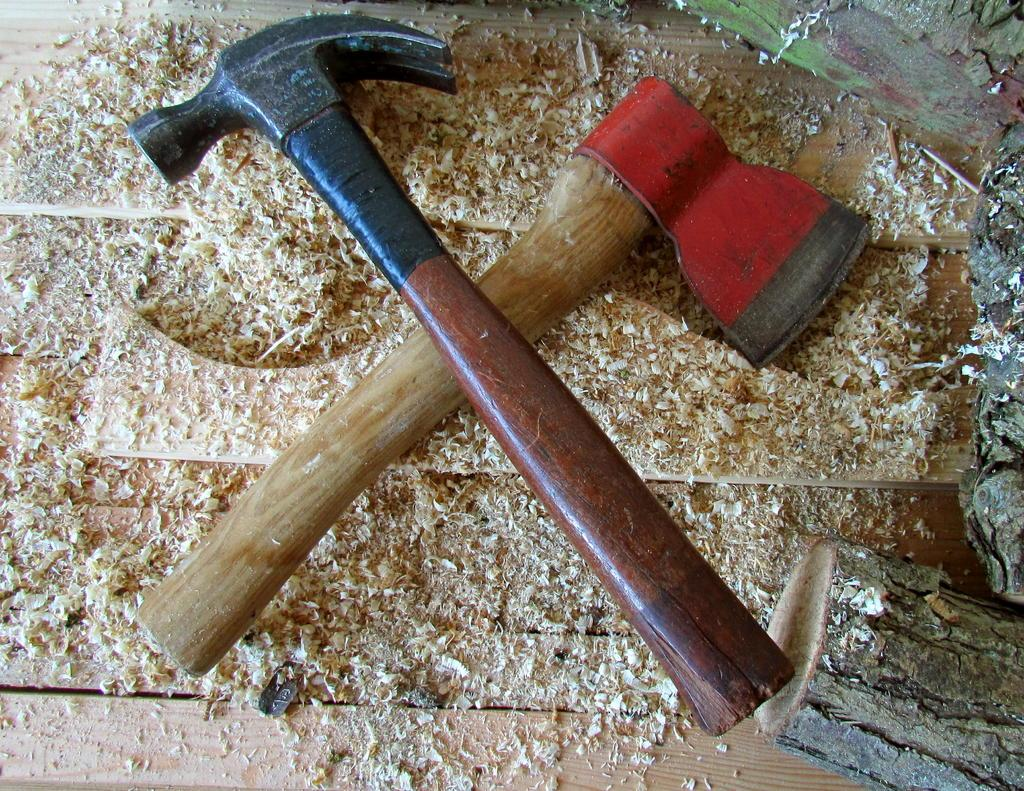What type of tools can be seen in the image? There is an axe and a hammer in the image. What objects are being worked on in the image? There are wooden logs in the image. What might be a byproduct of working with the wooden logs? There is sawdust on a wooden surface in the image, which could be a byproduct of working with the wooden logs. What type of ticket is visible in the image? There is no ticket present in the image. What is the relation between the axe and the hammer in the image? The axe and the hammer are separate tools in the image and do not have a direct relation to each other. 